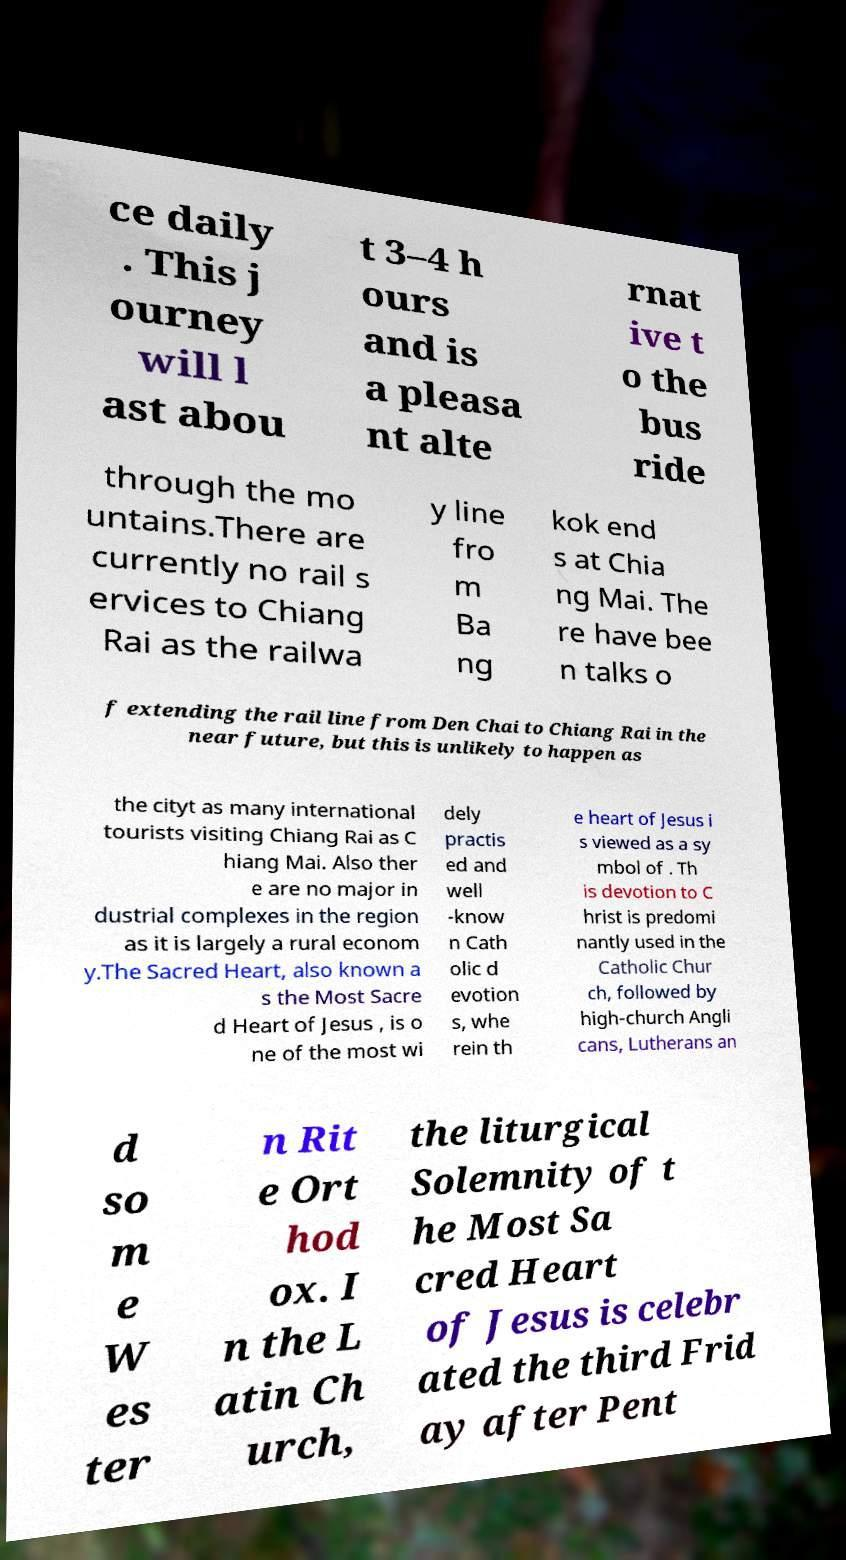For documentation purposes, I need the text within this image transcribed. Could you provide that? ce daily . This j ourney will l ast abou t 3–4 h ours and is a pleasa nt alte rnat ive t o the bus ride through the mo untains.There are currently no rail s ervices to Chiang Rai as the railwa y line fro m Ba ng kok end s at Chia ng Mai. The re have bee n talks o f extending the rail line from Den Chai to Chiang Rai in the near future, but this is unlikely to happen as the cityt as many international tourists visiting Chiang Rai as C hiang Mai. Also ther e are no major in dustrial complexes in the region as it is largely a rural econom y.The Sacred Heart, also known a s the Most Sacre d Heart of Jesus , is o ne of the most wi dely practis ed and well -know n Cath olic d evotion s, whe rein th e heart of Jesus i s viewed as a sy mbol of . Th is devotion to C hrist is predomi nantly used in the Catholic Chur ch, followed by high-church Angli cans, Lutherans an d so m e W es ter n Rit e Ort hod ox. I n the L atin Ch urch, the liturgical Solemnity of t he Most Sa cred Heart of Jesus is celebr ated the third Frid ay after Pent 